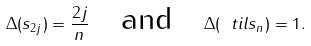<formula> <loc_0><loc_0><loc_500><loc_500>\Delta ( s _ { 2 j } ) = \frac { 2 j } { n } \quad \text {and} \quad \Delta ( \ t i l s _ { n } ) = 1 .</formula> 